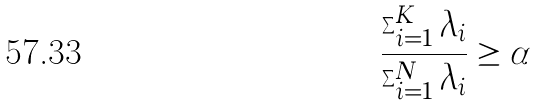Convert formula to latex. <formula><loc_0><loc_0><loc_500><loc_500>\frac { \sum _ { i = 1 } ^ { K } \lambda _ { i } } { \sum _ { i = 1 } ^ { N } \lambda _ { i } } \geq \alpha</formula> 